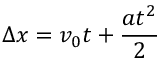<formula> <loc_0><loc_0><loc_500><loc_500>\Delta x = v _ { 0 } t + { \frac { a t ^ { 2 } } { 2 } }</formula> 